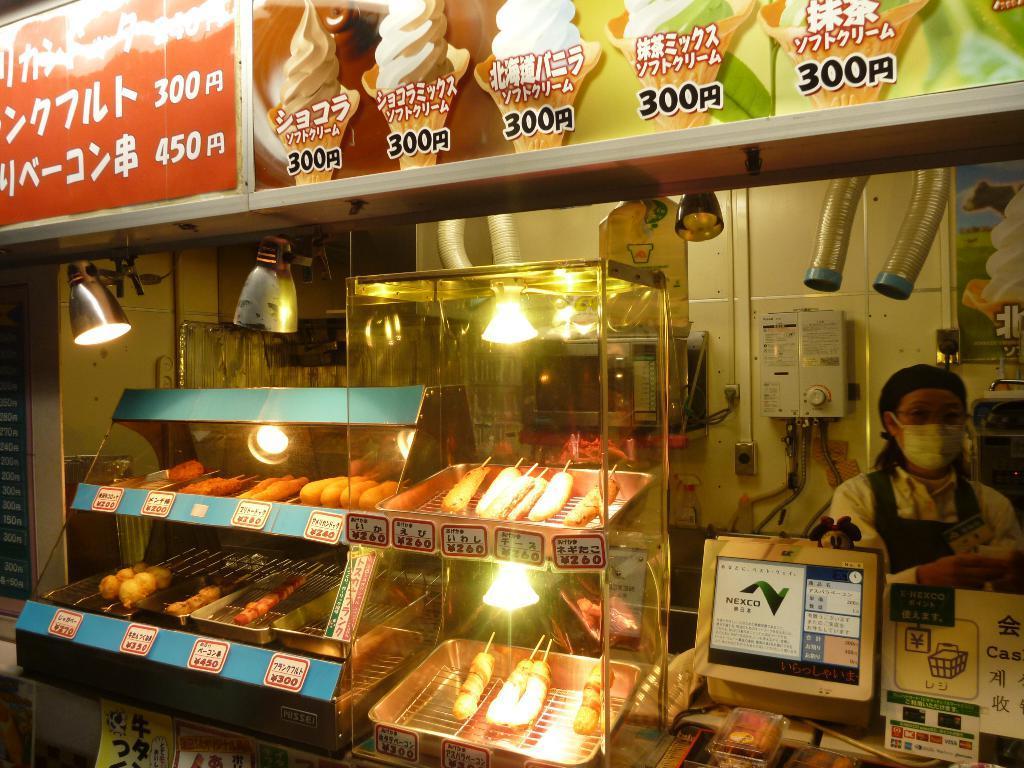Could you give a brief overview of what you see in this image? In this image I see boards on which there are pictures of ice creams and I see something is written and I see the glass containers over here on which there is food and I see the lights and I see a woman over here and I see a monitor over here and I see few equipment. 